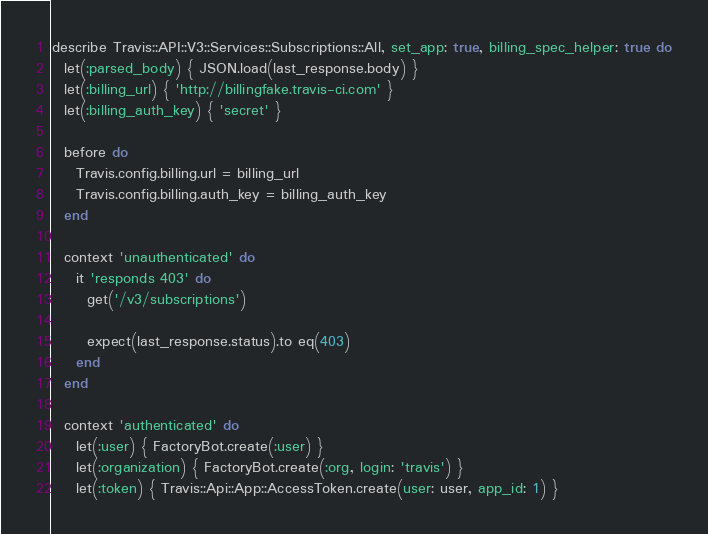<code> <loc_0><loc_0><loc_500><loc_500><_Ruby_>describe Travis::API::V3::Services::Subscriptions::All, set_app: true, billing_spec_helper: true do
  let(:parsed_body) { JSON.load(last_response.body) }
  let(:billing_url) { 'http://billingfake.travis-ci.com' }
  let(:billing_auth_key) { 'secret' }

  before do
    Travis.config.billing.url = billing_url
    Travis.config.billing.auth_key = billing_auth_key
  end

  context 'unauthenticated' do
    it 'responds 403' do
      get('/v3/subscriptions')

      expect(last_response.status).to eq(403)
    end
  end

  context 'authenticated' do
    let(:user) { FactoryBot.create(:user) }
    let(:organization) { FactoryBot.create(:org, login: 'travis') }
    let(:token) { Travis::Api::App::AccessToken.create(user: user, app_id: 1) }</code> 